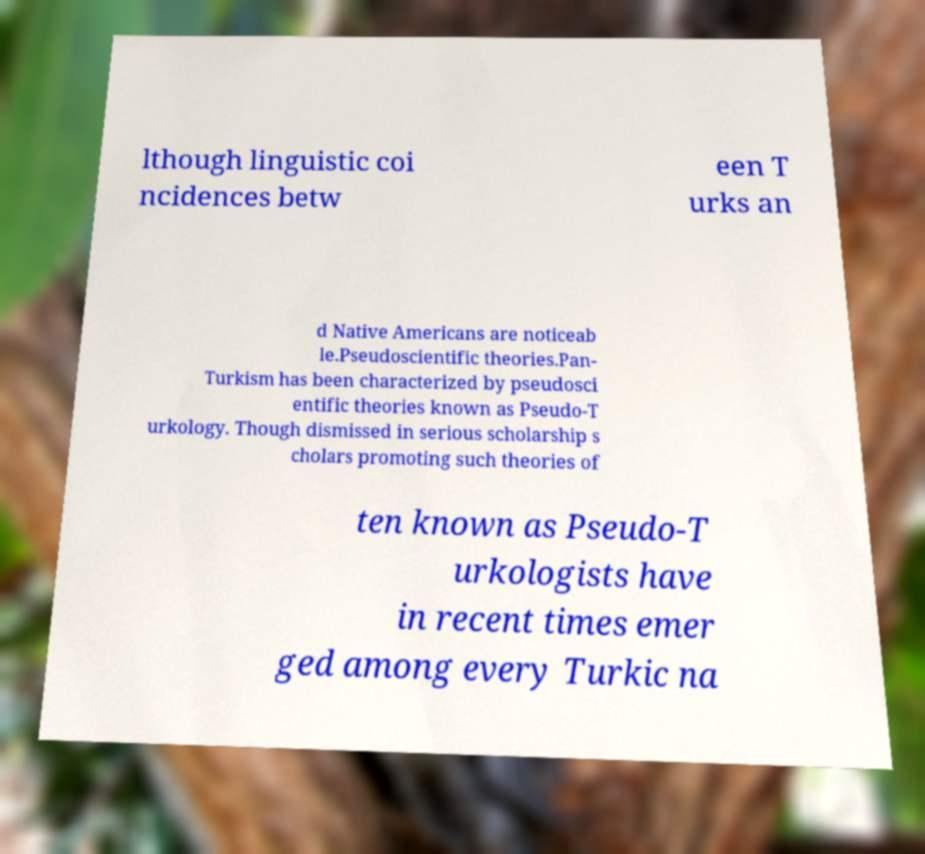Could you assist in decoding the text presented in this image and type it out clearly? lthough linguistic coi ncidences betw een T urks an d Native Americans are noticeab le.Pseudoscientific theories.Pan- Turkism has been characterized by pseudosci entific theories known as Pseudo-T urkology. Though dismissed in serious scholarship s cholars promoting such theories of ten known as Pseudo-T urkologists have in recent times emer ged among every Turkic na 